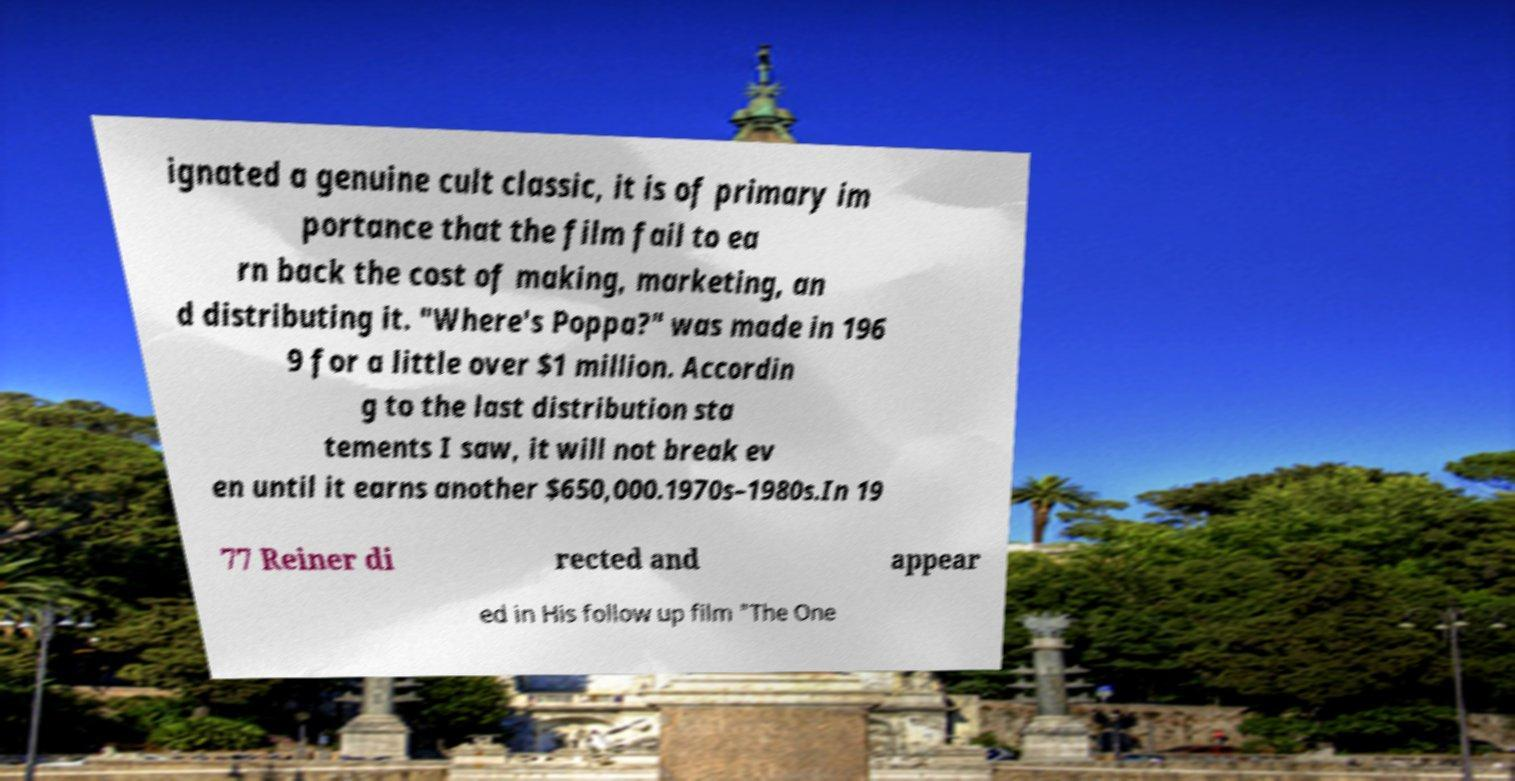Can you read and provide the text displayed in the image?This photo seems to have some interesting text. Can you extract and type it out for me? ignated a genuine cult classic, it is of primary im portance that the film fail to ea rn back the cost of making, marketing, an d distributing it. "Where's Poppa?" was made in 196 9 for a little over $1 million. Accordin g to the last distribution sta tements I saw, it will not break ev en until it earns another $650,000.1970s–1980s.In 19 77 Reiner di rected and appear ed in His follow up film "The One 